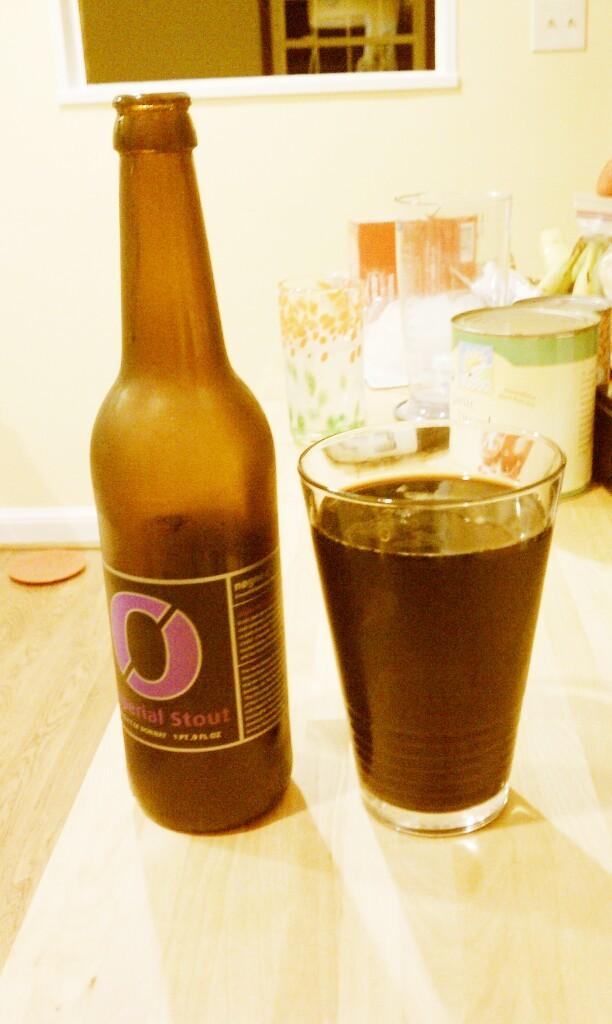What kind of beverage is this?
Make the answer very short. Stout. 